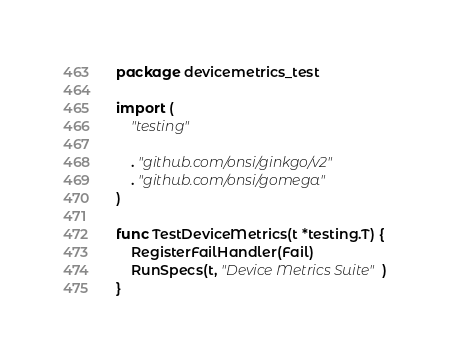<code> <loc_0><loc_0><loc_500><loc_500><_Go_>package devicemetrics_test

import (
	"testing"

	. "github.com/onsi/ginkgo/v2"
	. "github.com/onsi/gomega"
)

func TestDeviceMetrics(t *testing.T) {
	RegisterFailHandler(Fail)
	RunSpecs(t, "Device Metrics Suite")
}
</code> 